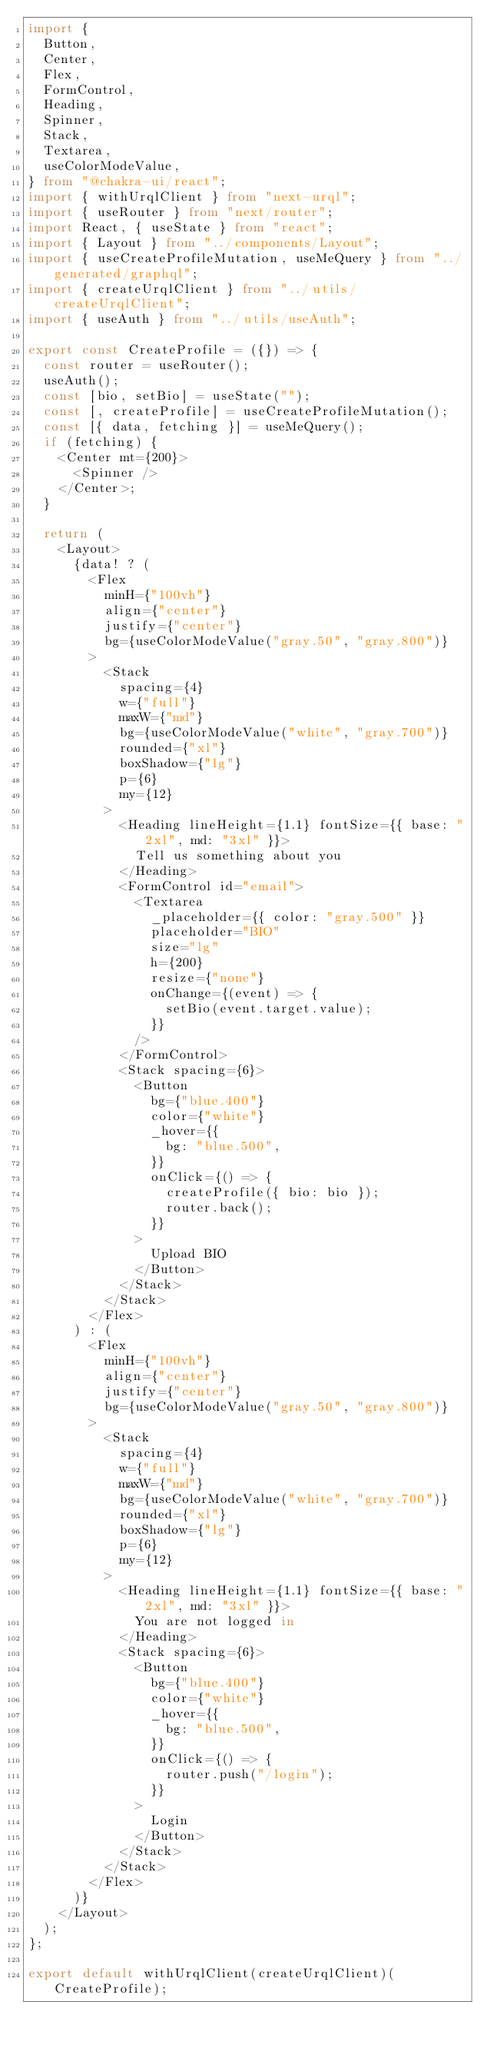<code> <loc_0><loc_0><loc_500><loc_500><_TypeScript_>import {
  Button,
  Center,
  Flex,
  FormControl,
  Heading,
  Spinner,
  Stack,
  Textarea,
  useColorModeValue,
} from "@chakra-ui/react";
import { withUrqlClient } from "next-urql";
import { useRouter } from "next/router";
import React, { useState } from "react";
import { Layout } from "../components/Layout";
import { useCreateProfileMutation, useMeQuery } from "../generated/graphql";
import { createUrqlClient } from "../utils/createUrqlClient";
import { useAuth } from "../utils/useAuth";

export const CreateProfile = ({}) => {
  const router = useRouter();
  useAuth();
  const [bio, setBio] = useState("");
  const [, createProfile] = useCreateProfileMutation();
  const [{ data, fetching }] = useMeQuery();
  if (fetching) {
    <Center mt={200}>
      <Spinner />
    </Center>;
  }

  return (
    <Layout>
      {data! ? (
        <Flex
          minH={"100vh"}
          align={"center"}
          justify={"center"}
          bg={useColorModeValue("gray.50", "gray.800")}
        >
          <Stack
            spacing={4}
            w={"full"}
            maxW={"md"}
            bg={useColorModeValue("white", "gray.700")}
            rounded={"xl"}
            boxShadow={"lg"}
            p={6}
            my={12}
          >
            <Heading lineHeight={1.1} fontSize={{ base: "2xl", md: "3xl" }}>
              Tell us something about you
            </Heading>
            <FormControl id="email">
              <Textarea
                _placeholder={{ color: "gray.500" }}
                placeholder="BIO"
                size="lg"
                h={200}
                resize={"none"}
                onChange={(event) => {
                  setBio(event.target.value);
                }}
              />
            </FormControl>
            <Stack spacing={6}>
              <Button
                bg={"blue.400"}
                color={"white"}
                _hover={{
                  bg: "blue.500",
                }}
                onClick={() => {
                  createProfile({ bio: bio });
                  router.back();
                }}
              >
                Upload BIO
              </Button>
            </Stack>
          </Stack>
        </Flex>
      ) : (
        <Flex
          minH={"100vh"}
          align={"center"}
          justify={"center"}
          bg={useColorModeValue("gray.50", "gray.800")}
        >
          <Stack
            spacing={4}
            w={"full"}
            maxW={"md"}
            bg={useColorModeValue("white", "gray.700")}
            rounded={"xl"}
            boxShadow={"lg"}
            p={6}
            my={12}
          >
            <Heading lineHeight={1.1} fontSize={{ base: "2xl", md: "3xl" }}>
              You are not logged in
            </Heading>
            <Stack spacing={6}>
              <Button
                bg={"blue.400"}
                color={"white"}
                _hover={{
                  bg: "blue.500",
                }}
                onClick={() => {
                  router.push("/login");
                }}
              >
                Login
              </Button>
            </Stack>
          </Stack>
        </Flex>
      )}
    </Layout>
  );
};

export default withUrqlClient(createUrqlClient)(CreateProfile);
</code> 